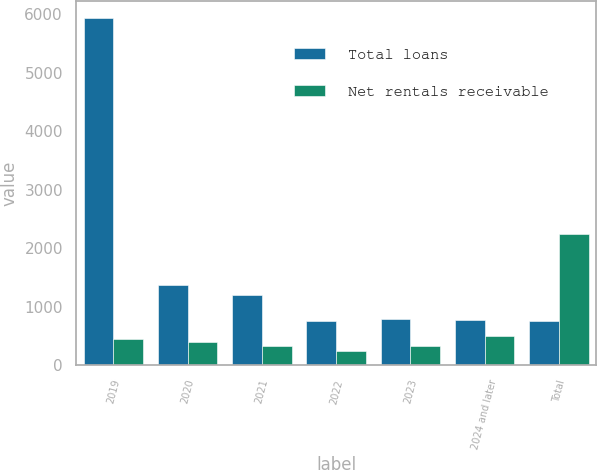Convert chart. <chart><loc_0><loc_0><loc_500><loc_500><stacked_bar_chart><ecel><fcel>2019<fcel>2020<fcel>2021<fcel>2022<fcel>2023<fcel>2024 and later<fcel>Total<nl><fcel>Total loans<fcel>5932<fcel>1371<fcel>1208<fcel>753<fcel>796<fcel>773<fcel>753<nl><fcel>Net rentals receivable<fcel>446<fcel>391<fcel>334<fcel>247<fcel>329<fcel>497<fcel>2245<nl></chart> 